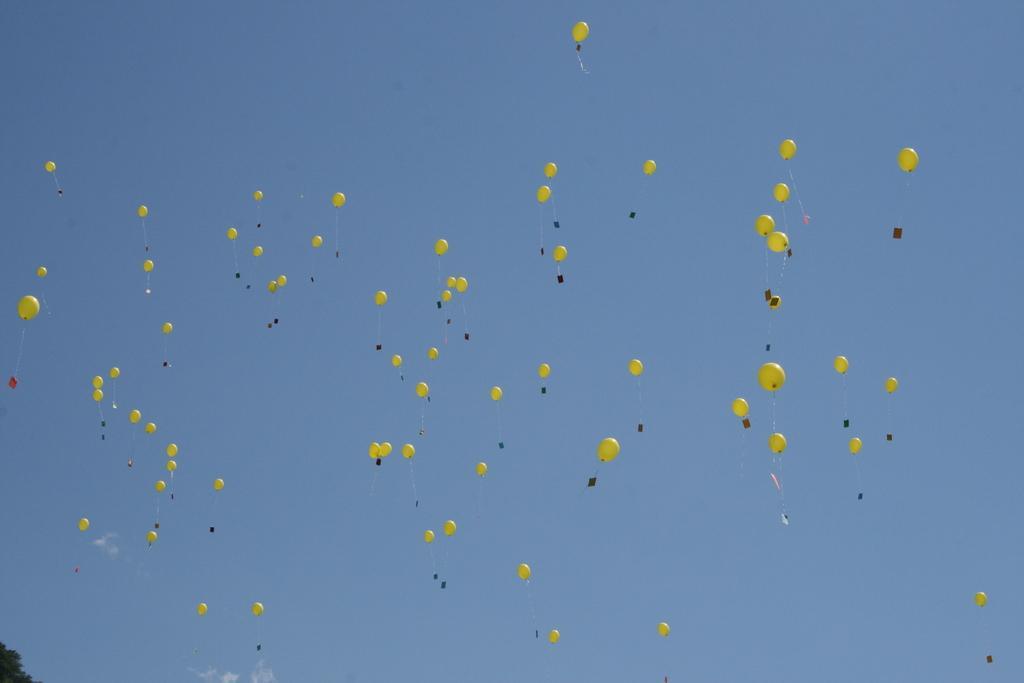Please provide a concise description of this image. Here I can see few yellow color balloons flying in the air. In the background, I can see the sky in blue color. In the bottom left-hand corner few leaves are visible. 